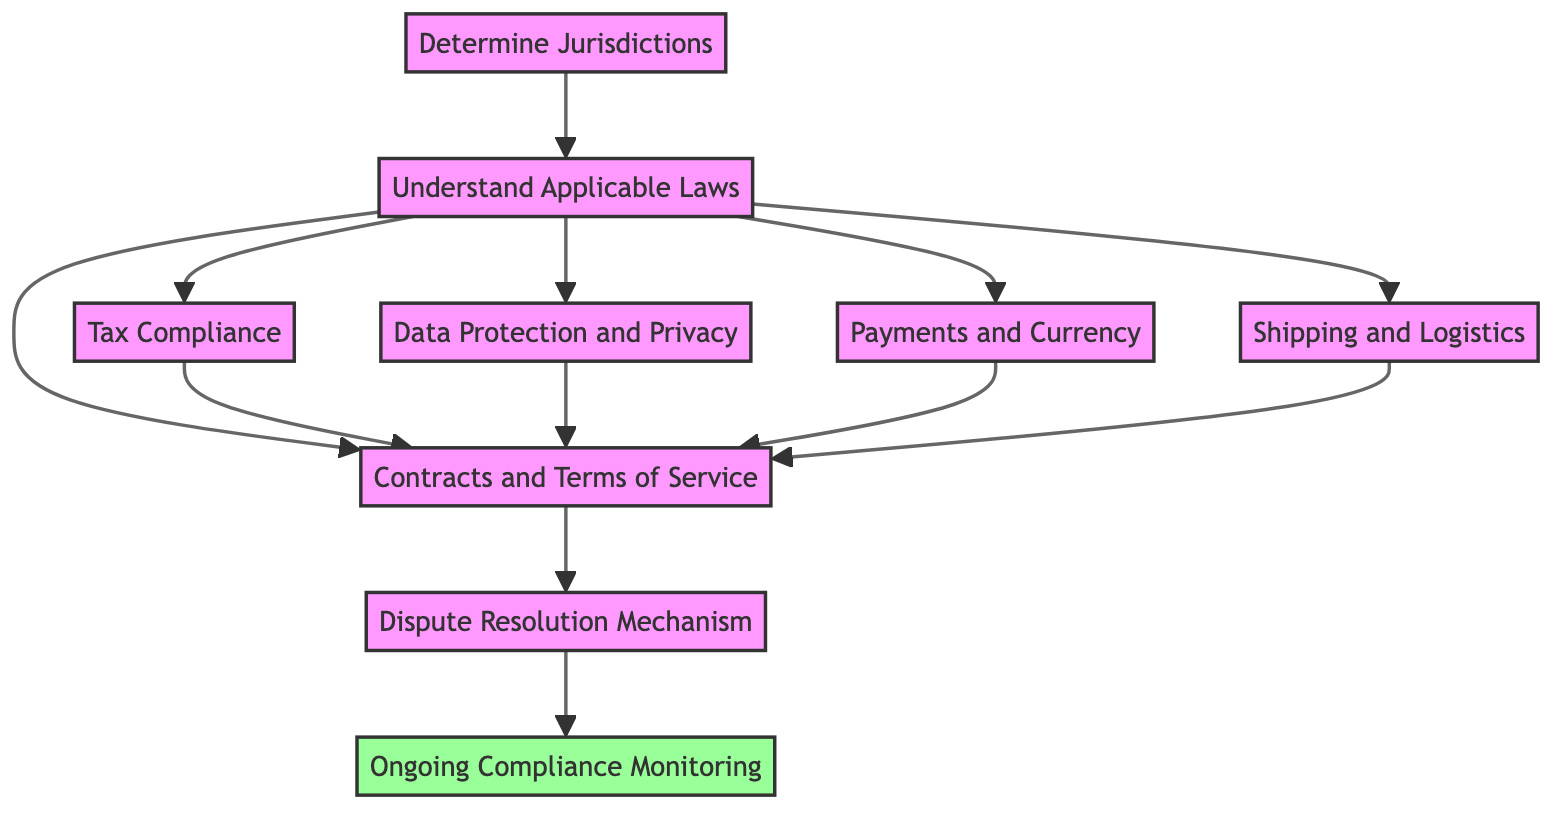What is the first step in the flowchart? The first step in the flowchart is represented by the node "Determine Jurisdictions," which is the starting point for the regulatory steps in cross-border e-commerce transactions.
Answer: Determine Jurisdictions How many nodes are there in the diagram? The diagram consists of nine nodes, each representing a distinct regulatory step necessary for cross-border e-commerce transactions.
Answer: 9 Which step comes after "Understand Applicable Laws"? The steps that directly follow "Understand Applicable Laws" include "Tax Compliance," "Data Protection and Privacy," "Payments and Currency," and "Shipping and Logistics," indicating multiple pathways.
Answer: Tax Compliance, Data Protection and Privacy, Payments and Currency, Shipping and Logistics What is the last step of the process? The last step of the process is "Ongoing Compliance Monitoring," indicating the need for continuous adherence to changing regulations after all prior steps are completed.
Answer: Ongoing Compliance Monitoring What is required to establish a "Dispute Resolution Mechanism"? To establish a "Dispute Resolution Mechanism," it is essential to first complete the "Contracts and Terms of Service" step, which addresses issues related to jurisdictions and arbitration clauses.
Answer: Contracts and Terms of Service How many dependencies does "Contracts and Terms of Service" have? The "Contracts and Terms of Service" step has five dependencies; it relies on the completion of "Understand Applicable Laws," "Tax Compliance," "Data Protection and Privacy," "Payments and Currency," and "Shipping and Logistics."
Answer: 5 What step must be completed before establishing "Dispute Resolution Mechanism"? Before establishing the "Dispute Resolution Mechanism," the step "Contracts and Terms of Service" must be completed as it provides the framework for dispute handling.
Answer: Contracts and Terms of Service Which steps require compliance with laws specific to data protection? The steps requiring compliance with data protection laws include "Data Protection and Privacy" and "Contracts and Terms of Service," as both involve ensuring adherence to such regulations.
Answer: Data Protection and Privacy, Contracts and Terms of Service What is the relationship between "Tax Compliance" and "Contracts and Terms of Service"? "Tax Compliance" directly influences the "Contracts and Terms of Service" as it is a dependency, indicating that understanding tax obligations is necessary when drafting contracts.
Answer: Tax Compliance is a dependency 